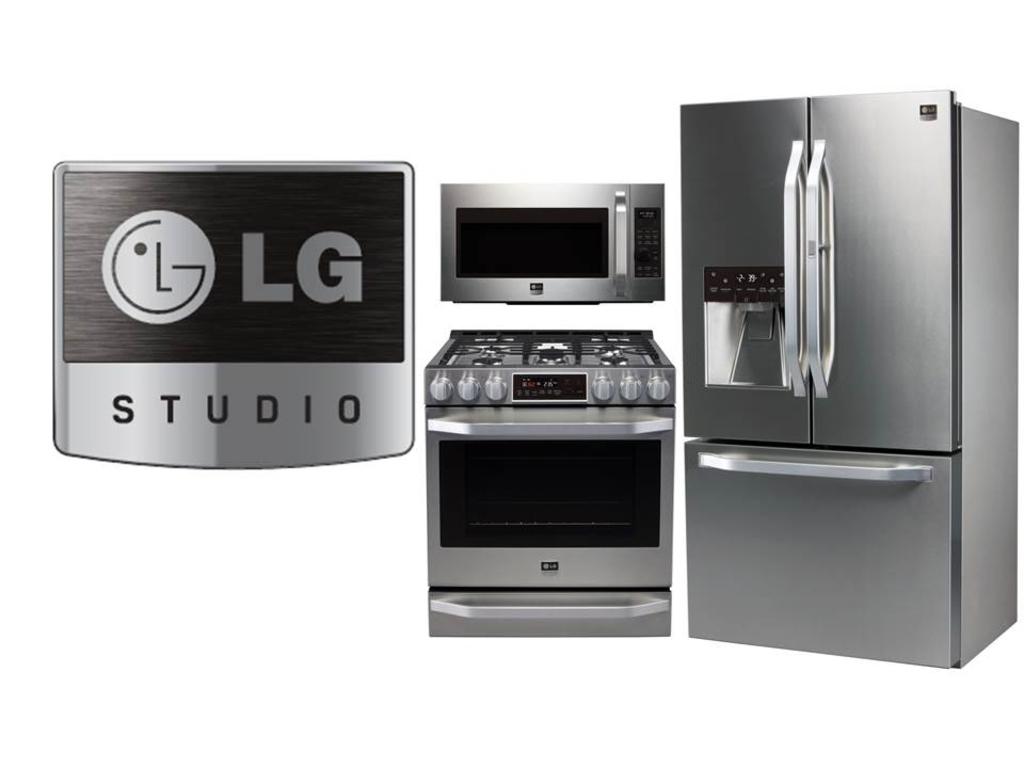What brand of fridge is this?
Keep it short and to the point. Lg. 